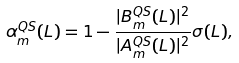<formula> <loc_0><loc_0><loc_500><loc_500>\alpha _ { m } ^ { Q S } ( L ) = 1 - \frac { | B _ { m } ^ { Q S } ( L ) | ^ { 2 } } { | A _ { m } ^ { Q S } ( L ) | ^ { 2 } } \sigma ( L ) ,</formula> 